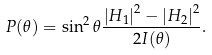<formula> <loc_0><loc_0><loc_500><loc_500>P ( \theta ) = \sin ^ { 2 } \theta \frac { \left | H _ { 1 } \right | ^ { 2 } - \left | H _ { 2 } \right | ^ { 2 } } { 2 I ( \theta ) } .</formula> 